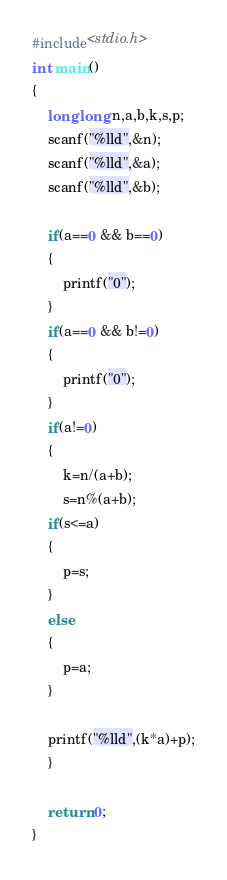Convert code to text. <code><loc_0><loc_0><loc_500><loc_500><_C_>#include<stdio.h>
int main()
{
    long long n,a,b,k,s,p;
    scanf("%lld",&n);
    scanf("%lld",&a);
    scanf("%lld",&b);

    if(a==0 && b==0)
    {
        printf("0");
    }
    if(a==0 && b!=0)
    {
        printf("0");
    }
    if(a!=0)
    {
        k=n/(a+b);
        s=n%(a+b);
    if(s<=a)
    {
        p=s;
    }
    else
    {
        p=a;
    }

    printf("%lld",(k*a)+p);
    }

    return 0;
}
</code> 